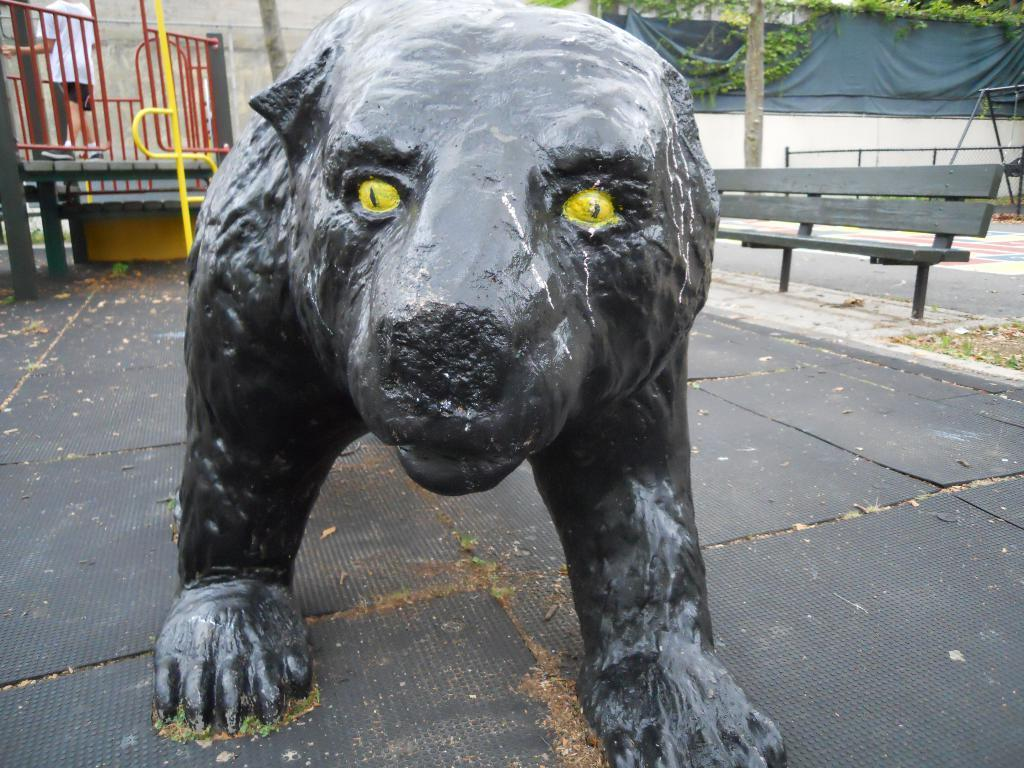What can be seen in the background of the image? There is a wall and plants in the background of the image. What type of seating is present in the image? There is a bench in the image. What type of pathway is visible in the image? There is a road in the image. What kind of artwork is featured in the image? There is a statue of an animal in the image. What type of food is being served on the bench in the image? There is no food present in the image, and the bench is not being used for serving food. What kind of trouble is the animal statue causing in the image? There is no indication of trouble or any negative situation involving the animal statue in the image. 